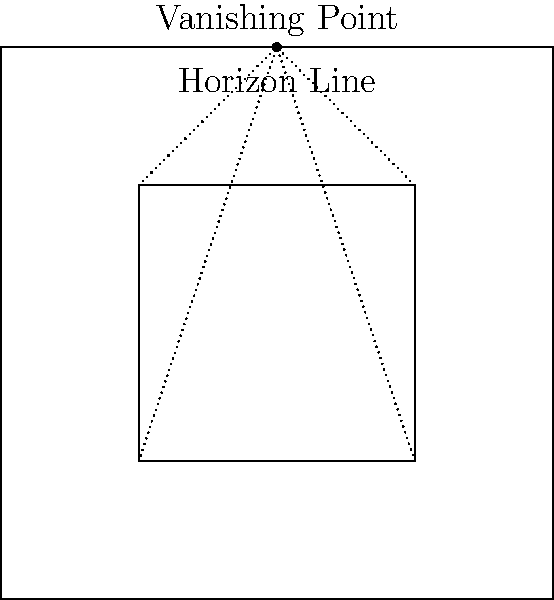In this one-point perspective drawing for an anime background, what is the relationship between the inner rectangle (EFGH) and the outer rectangle (ABCD), and how does this contribute to the illusion of depth? To understand the relationship between the inner and outer rectangles in this one-point perspective drawing:

1. Observe that the outer rectangle (ABCD) represents the frame of the scene.
2. The inner rectangle (EFGH) is a smaller version of the outer rectangle, positioned closer to the center.
3. Notice that the horizon line is drawn near the top of the frame, with the vanishing point located at its center.
4. The dotted lines connecting the corners of the inner rectangle (E, F, G, H) to the vanishing point demonstrate the perspective effect.
5. These lines create the illusion that the inner rectangle is receding into the distance.
6. The inner rectangle appears to be a window or opening within the larger scene.
7. The proportional reduction in size of the inner rectangle relative to the outer one creates a sense of depth and distance.
8. This technique is commonly used in anime backgrounds to add depth and dimension to 2D scenes.
9. By manipulating the size and position of the inner rectangle, artists can control the perceived distance and spatial relationships within the scene.

The relationship between the two rectangles, combined with the perspective lines converging at the vanishing point, effectively creates the illusion of depth in this 2D drawing.
Answer: The inner rectangle is a proportionally smaller version of the outer rectangle, with perspective lines converging at the vanishing point, creating the illusion of depth. 